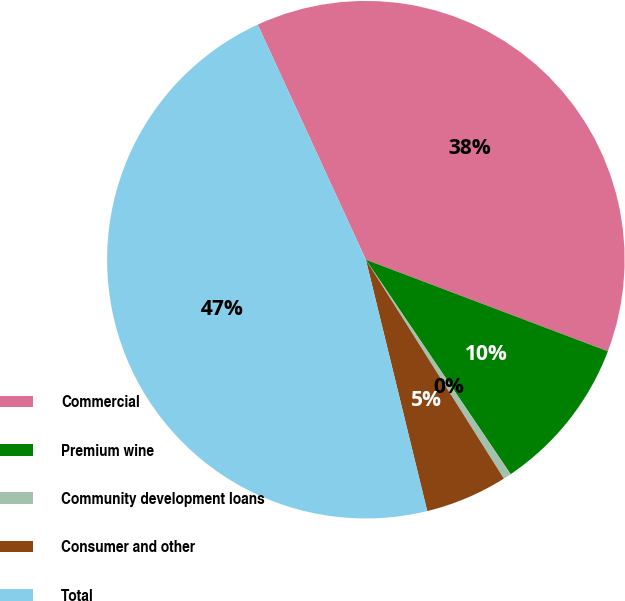<chart> <loc_0><loc_0><loc_500><loc_500><pie_chart><fcel>Commercial<fcel>Premium wine<fcel>Community development loans<fcel>Consumer and other<fcel>Total<nl><fcel>37.62%<fcel>9.79%<fcel>0.5%<fcel>5.14%<fcel>46.95%<nl></chart> 